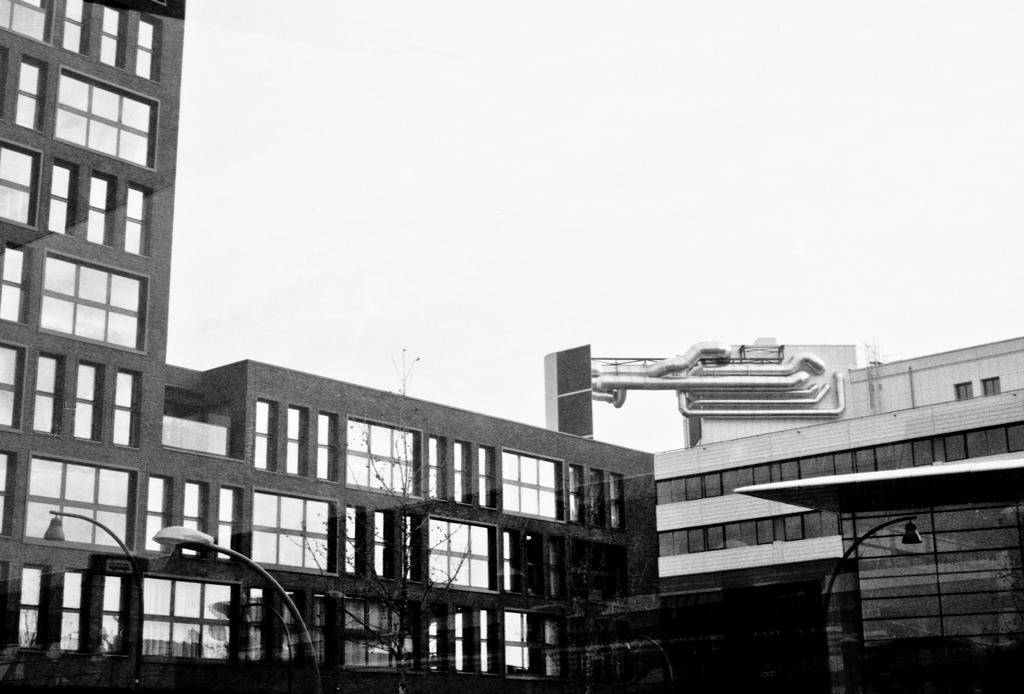What type of structures can be seen in the image? There are buildings in the image. What else can be seen in the image besides buildings? There are poles, lights, trees, and the sky visible in the image. What are the poles used for in the image? The poles are likely used to support the lights in the image. What is the background of the image? The sky is visible in the background of the image. What type of ice can be seen melting on the buildings in the image? There is no ice present in the image; it features buildings, poles, lights, trees, and the sky. 